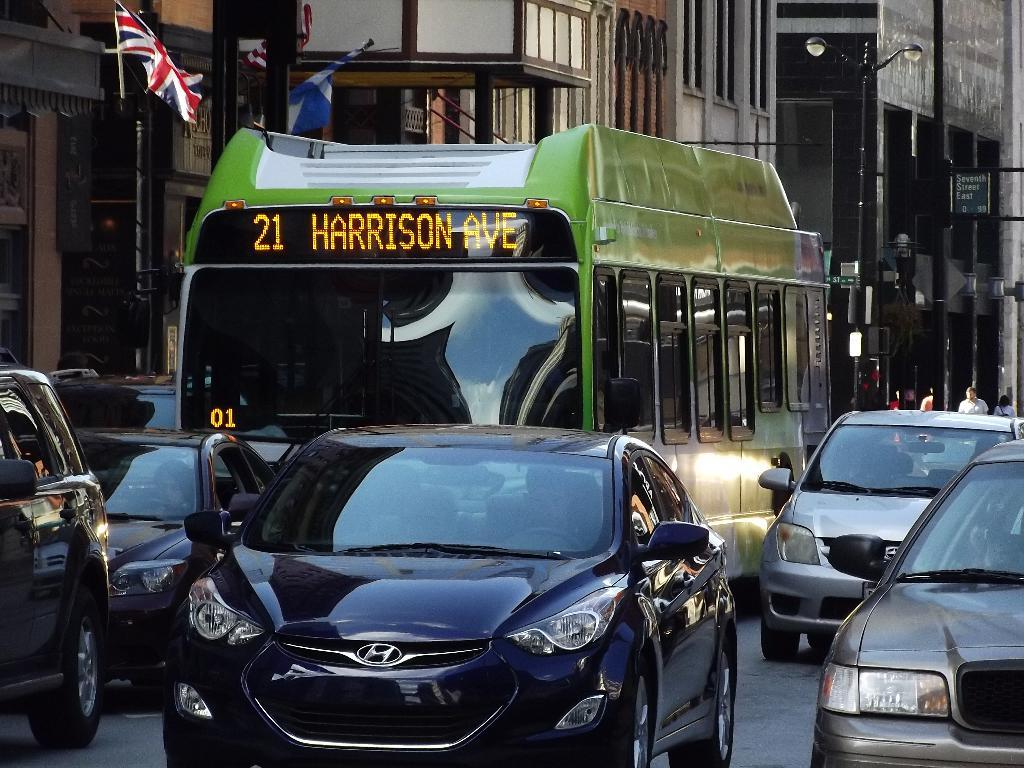What can be seen on the road in the image? There are vehicles on the road in the image. What is visible in the background of the image? There are flags, buildings, and street lights in the background of the image. What type of cork can be seen in the image? There is no cork present in the image. What tool is being used to fix the machine in the image? There is no machine or tool present in the image. 